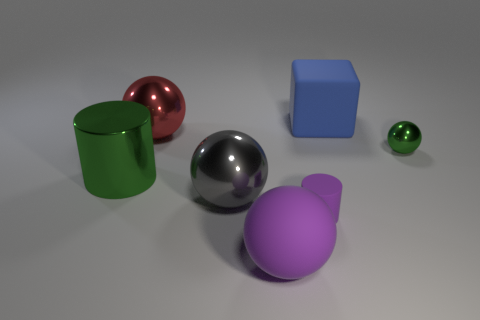Subtract all yellow balls. Subtract all brown cylinders. How many balls are left? 4 Add 2 big gray shiny things. How many objects exist? 9 Subtract all blocks. How many objects are left? 6 Subtract 1 red balls. How many objects are left? 6 Subtract all red metallic things. Subtract all big green metal cylinders. How many objects are left? 5 Add 3 cylinders. How many cylinders are left? 5 Add 4 big blue rubber objects. How many big blue rubber objects exist? 5 